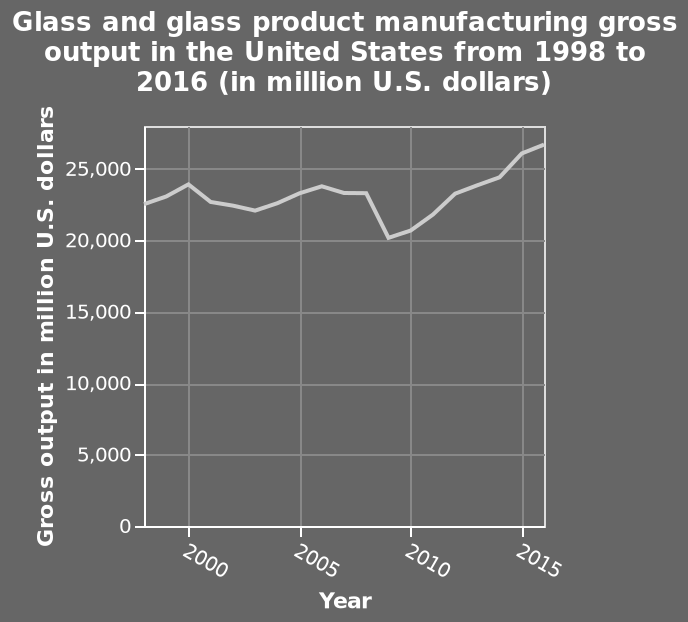<image>
What was the gross output in 1998?  The gross output in 1998 was approximately 23,000 million USD. When did the gross output drop significantly? The gross output dropped significantly to 20,000 million USD around 2009. 